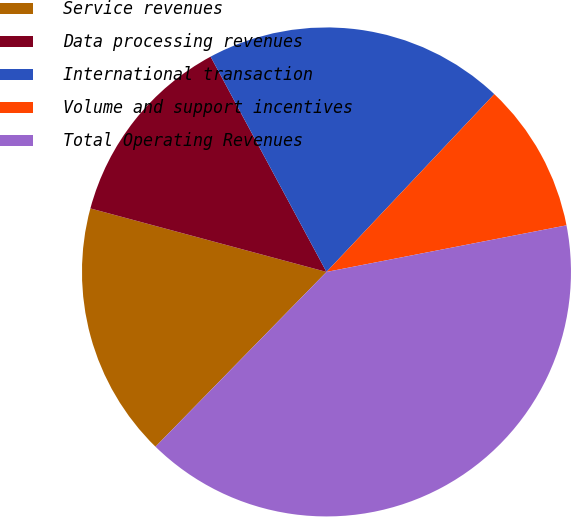<chart> <loc_0><loc_0><loc_500><loc_500><pie_chart><fcel>Service revenues<fcel>Data processing revenues<fcel>International transaction<fcel>Volume and support incentives<fcel>Total Operating Revenues<nl><fcel>16.86%<fcel>12.96%<fcel>19.9%<fcel>9.91%<fcel>40.38%<nl></chart> 